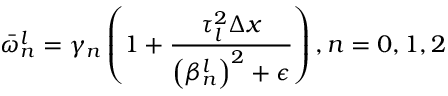<formula> <loc_0><loc_0><loc_500><loc_500>\bar { \omega } _ { n } ^ { l } = \gamma _ { n } \left ( 1 + \frac { \tau _ { l } ^ { 2 } \Delta x } { \left ( \beta _ { n } ^ { l } \right ) ^ { 2 } + \epsilon } \right ) , n = 0 , 1 , 2</formula> 